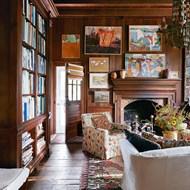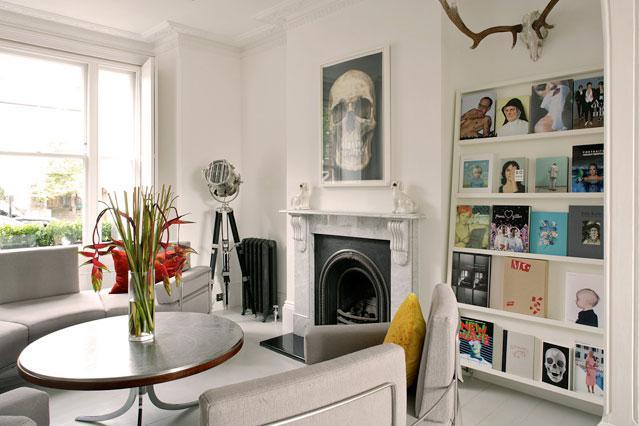The first image is the image on the left, the second image is the image on the right. For the images shown, is this caption "In one image, a television is centered in a white wall unit that has open shelving in the upper section and solid panel doors and drawers across the bottom" true? Answer yes or no. No. The first image is the image on the left, the second image is the image on the right. Considering the images on both sides, is "A large flat-screen TV is flanked by vertical white bookshelves in one of the rooms." valid? Answer yes or no. No. 